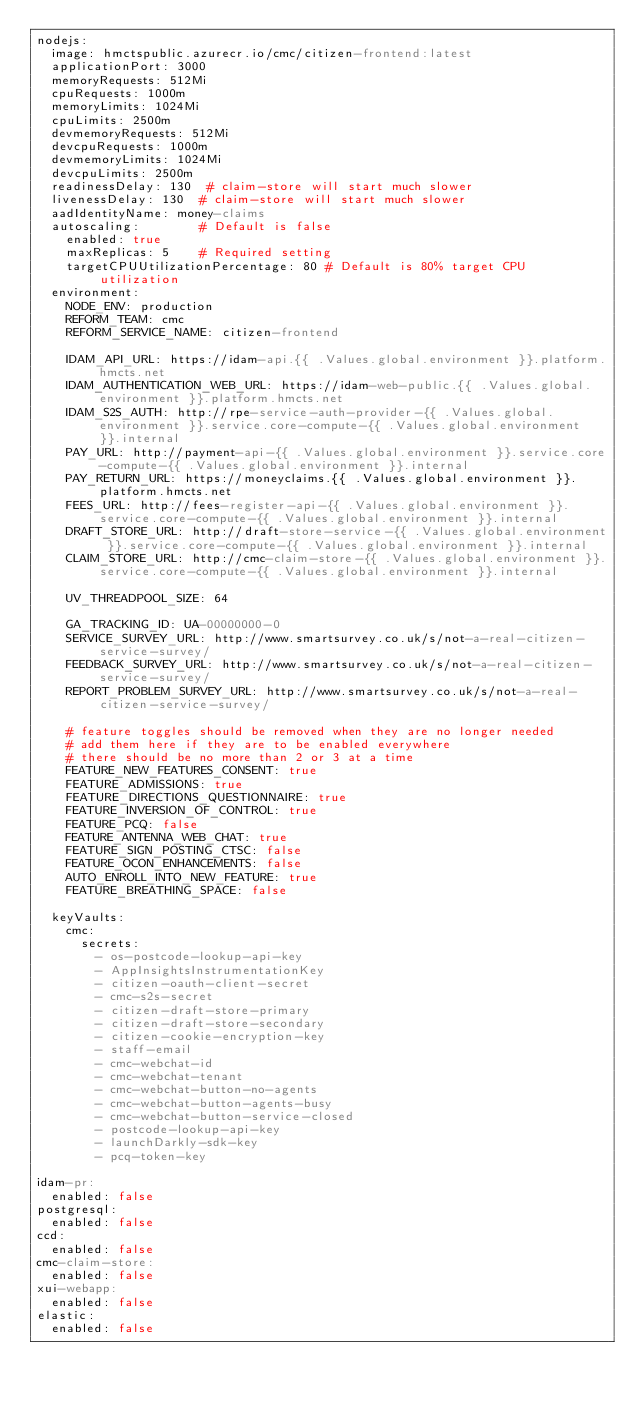<code> <loc_0><loc_0><loc_500><loc_500><_YAML_>nodejs:
  image: hmctspublic.azurecr.io/cmc/citizen-frontend:latest
  applicationPort: 3000
  memoryRequests: 512Mi
  cpuRequests: 1000m
  memoryLimits: 1024Mi
  cpuLimits: 2500m
  devmemoryRequests: 512Mi
  devcpuRequests: 1000m
  devmemoryLimits: 1024Mi
  devcpuLimits: 2500m
  readinessDelay: 130  # claim-store will start much slower
  livenessDelay: 130  # claim-store will start much slower
  aadIdentityName: money-claims
  autoscaling:        # Default is false
    enabled: true
    maxReplicas: 5    # Required setting
    targetCPUUtilizationPercentage: 80 # Default is 80% target CPU utilization
  environment:
    NODE_ENV: production
    REFORM_TEAM: cmc
    REFORM_SERVICE_NAME: citizen-frontend

    IDAM_API_URL: https://idam-api.{{ .Values.global.environment }}.platform.hmcts.net
    IDAM_AUTHENTICATION_WEB_URL: https://idam-web-public.{{ .Values.global.environment }}.platform.hmcts.net
    IDAM_S2S_AUTH: http://rpe-service-auth-provider-{{ .Values.global.environment }}.service.core-compute-{{ .Values.global.environment }}.internal
    PAY_URL: http://payment-api-{{ .Values.global.environment }}.service.core-compute-{{ .Values.global.environment }}.internal
    PAY_RETURN_URL: https://moneyclaims.{{ .Values.global.environment }}.platform.hmcts.net
    FEES_URL: http://fees-register-api-{{ .Values.global.environment }}.service.core-compute-{{ .Values.global.environment }}.internal
    DRAFT_STORE_URL: http://draft-store-service-{{ .Values.global.environment }}.service.core-compute-{{ .Values.global.environment }}.internal
    CLAIM_STORE_URL: http://cmc-claim-store-{{ .Values.global.environment }}.service.core-compute-{{ .Values.global.environment }}.internal

    UV_THREADPOOL_SIZE: 64

    GA_TRACKING_ID: UA-00000000-0
    SERVICE_SURVEY_URL: http://www.smartsurvey.co.uk/s/not-a-real-citizen-service-survey/
    FEEDBACK_SURVEY_URL: http://www.smartsurvey.co.uk/s/not-a-real-citizen-service-survey/
    REPORT_PROBLEM_SURVEY_URL: http://www.smartsurvey.co.uk/s/not-a-real-citizen-service-survey/

    # feature toggles should be removed when they are no longer needed
    # add them here if they are to be enabled everywhere
    # there should be no more than 2 or 3 at a time
    FEATURE_NEW_FEATURES_CONSENT: true
    FEATURE_ADMISSIONS: true
    FEATURE_DIRECTIONS_QUESTIONNAIRE: true
    FEATURE_INVERSION_OF_CONTROL: true
    FEATURE_PCQ: false
    FEATURE_ANTENNA_WEB_CHAT: true
    FEATURE_SIGN_POSTING_CTSC: false
    FEATURE_OCON_ENHANCEMENTS: false
    AUTO_ENROLL_INTO_NEW_FEATURE: true
    FEATURE_BREATHING_SPACE: false

  keyVaults:
    cmc:
      secrets:
        - os-postcode-lookup-api-key
        - AppInsightsInstrumentationKey
        - citizen-oauth-client-secret
        - cmc-s2s-secret
        - citizen-draft-store-primary
        - citizen-draft-store-secondary
        - citizen-cookie-encryption-key
        - staff-email
        - cmc-webchat-id
        - cmc-webchat-tenant
        - cmc-webchat-button-no-agents
        - cmc-webchat-button-agents-busy
        - cmc-webchat-button-service-closed
        - postcode-lookup-api-key
        - launchDarkly-sdk-key
        - pcq-token-key

idam-pr:
  enabled: false
postgresql:
  enabled: false
ccd:
  enabled: false
cmc-claim-store:
  enabled: false
xui-webapp:
  enabled: false
elastic:
  enabled: false
</code> 